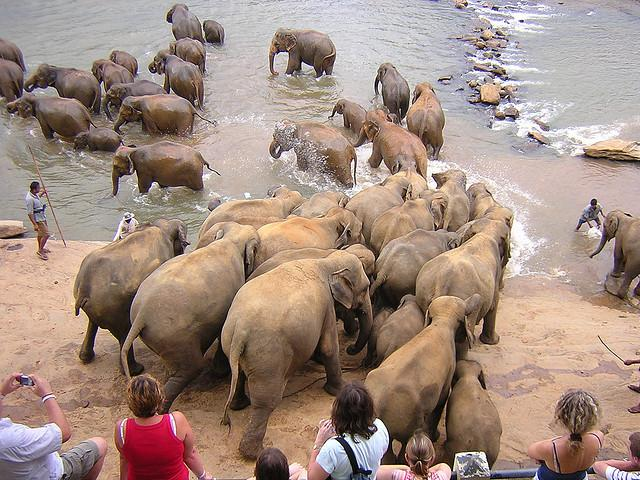Why is the man holding a camera?

Choices:
A) buying it
B) selling it
C) taking pictures
D) weighing it taking pictures 